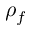Convert formula to latex. <formula><loc_0><loc_0><loc_500><loc_500>\rho _ { f }</formula> 